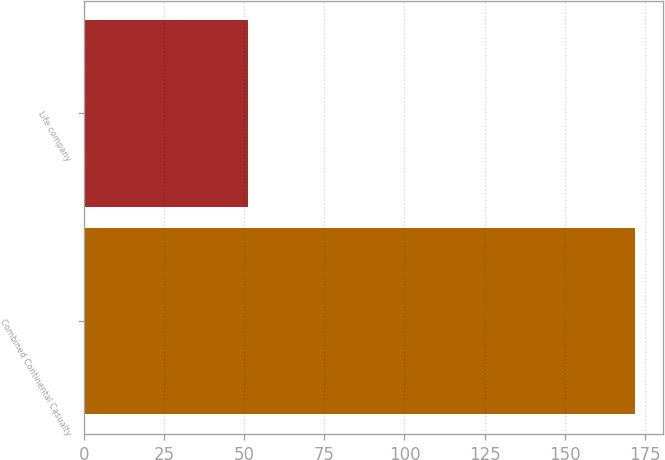<chart> <loc_0><loc_0><loc_500><loc_500><bar_chart><fcel>Combined Continental Casualty<fcel>Life company<nl><fcel>172<fcel>51<nl></chart> 